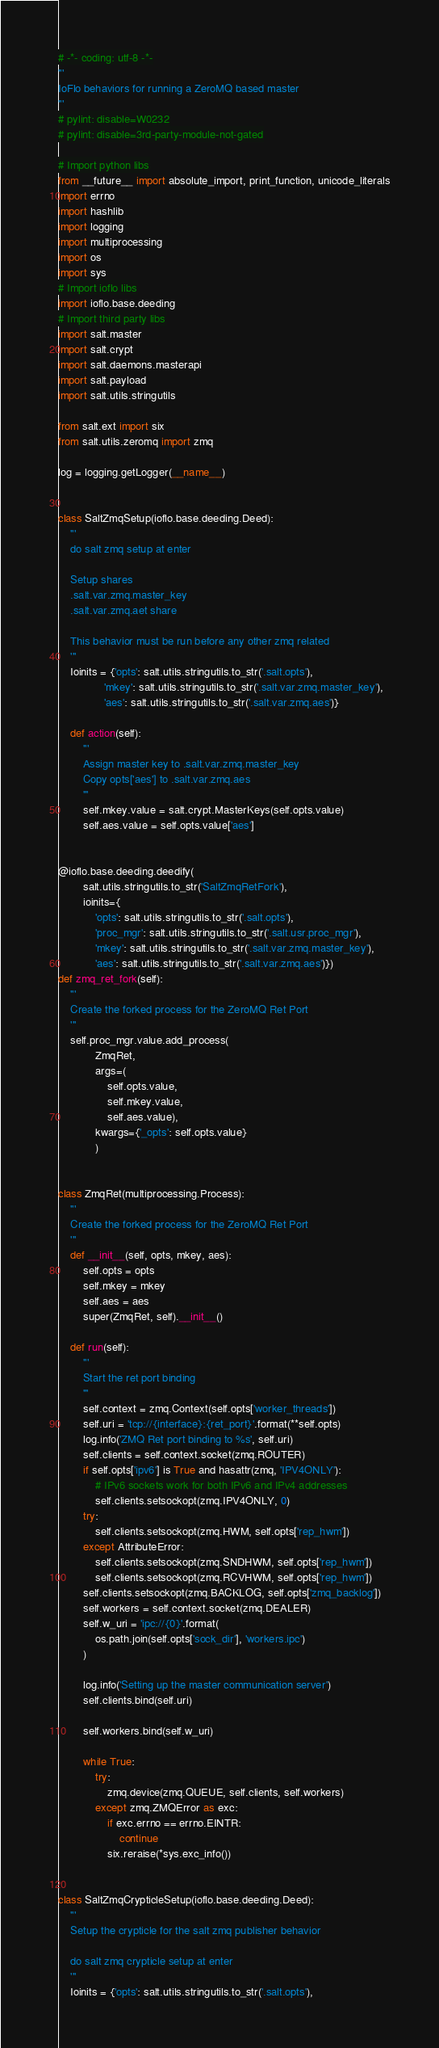<code> <loc_0><loc_0><loc_500><loc_500><_Python_># -*- coding: utf-8 -*-
'''
IoFlo behaviors for running a ZeroMQ based master
'''
# pylint: disable=W0232
# pylint: disable=3rd-party-module-not-gated

# Import python libs
from __future__ import absolute_import, print_function, unicode_literals
import errno
import hashlib
import logging
import multiprocessing
import os
import sys
# Import ioflo libs
import ioflo.base.deeding
# Import third party libs
import salt.master
import salt.crypt
import salt.daemons.masterapi
import salt.payload
import salt.utils.stringutils

from salt.ext import six
from salt.utils.zeromq import zmq

log = logging.getLogger(__name__)


class SaltZmqSetup(ioflo.base.deeding.Deed):
    '''
    do salt zmq setup at enter

    Setup shares
    .salt.var.zmq.master_key
    .salt.var.zmq.aet share

    This behavior must be run before any other zmq related
    '''
    Ioinits = {'opts': salt.utils.stringutils.to_str('.salt.opts'),
               'mkey': salt.utils.stringutils.to_str('.salt.var.zmq.master_key'),
               'aes': salt.utils.stringutils.to_str('.salt.var.zmq.aes')}

    def action(self):
        '''
        Assign master key to .salt.var.zmq.master_key
        Copy opts['aes'] to .salt.var.zmq.aes
        '''
        self.mkey.value = salt.crypt.MasterKeys(self.opts.value)
        self.aes.value = self.opts.value['aes']


@ioflo.base.deeding.deedify(
        salt.utils.stringutils.to_str('SaltZmqRetFork'),
        ioinits={
            'opts': salt.utils.stringutils.to_str('.salt.opts'),
            'proc_mgr': salt.utils.stringutils.to_str('.salt.usr.proc_mgr'),
            'mkey': salt.utils.stringutils.to_str('.salt.var.zmq.master_key'),
            'aes': salt.utils.stringutils.to_str('.salt.var.zmq.aes')})
def zmq_ret_fork(self):
    '''
    Create the forked process for the ZeroMQ Ret Port
    '''
    self.proc_mgr.value.add_process(
            ZmqRet,
            args=(
                self.opts.value,
                self.mkey.value,
                self.aes.value),
            kwargs={'_opts': self.opts.value}
            )


class ZmqRet(multiprocessing.Process):
    '''
    Create the forked process for the ZeroMQ Ret Port
    '''
    def __init__(self, opts, mkey, aes):
        self.opts = opts
        self.mkey = mkey
        self.aes = aes
        super(ZmqRet, self).__init__()

    def run(self):
        '''
        Start the ret port binding
        '''
        self.context = zmq.Context(self.opts['worker_threads'])
        self.uri = 'tcp://{interface}:{ret_port}'.format(**self.opts)
        log.info('ZMQ Ret port binding to %s', self.uri)
        self.clients = self.context.socket(zmq.ROUTER)
        if self.opts['ipv6'] is True and hasattr(zmq, 'IPV4ONLY'):
            # IPv6 sockets work for both IPv6 and IPv4 addresses
            self.clients.setsockopt(zmq.IPV4ONLY, 0)
        try:
            self.clients.setsockopt(zmq.HWM, self.opts['rep_hwm'])
        except AttributeError:
            self.clients.setsockopt(zmq.SNDHWM, self.opts['rep_hwm'])
            self.clients.setsockopt(zmq.RCVHWM, self.opts['rep_hwm'])
        self.clients.setsockopt(zmq.BACKLOG, self.opts['zmq_backlog'])
        self.workers = self.context.socket(zmq.DEALER)
        self.w_uri = 'ipc://{0}'.format(
            os.path.join(self.opts['sock_dir'], 'workers.ipc')
        )

        log.info('Setting up the master communication server')
        self.clients.bind(self.uri)

        self.workers.bind(self.w_uri)

        while True:
            try:
                zmq.device(zmq.QUEUE, self.clients, self.workers)
            except zmq.ZMQError as exc:
                if exc.errno == errno.EINTR:
                    continue
                six.reraise(*sys.exc_info())


class SaltZmqCrypticleSetup(ioflo.base.deeding.Deed):
    '''
    Setup the crypticle for the salt zmq publisher behavior

    do salt zmq crypticle setup at enter
    '''
    Ioinits = {'opts': salt.utils.stringutils.to_str('.salt.opts'),</code> 